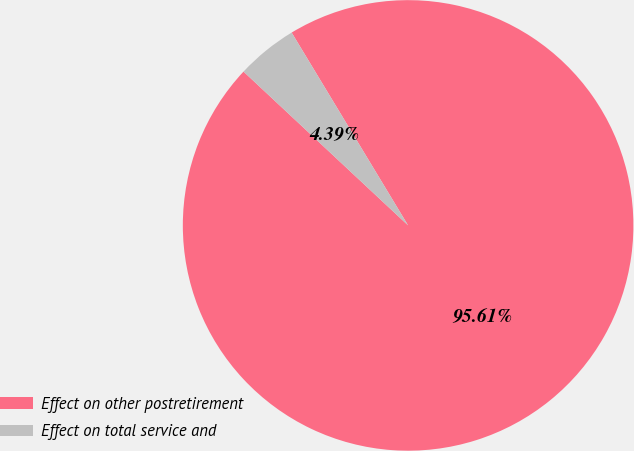Convert chart to OTSL. <chart><loc_0><loc_0><loc_500><loc_500><pie_chart><fcel>Effect on other postretirement<fcel>Effect on total service and<nl><fcel>95.61%<fcel>4.39%<nl></chart> 